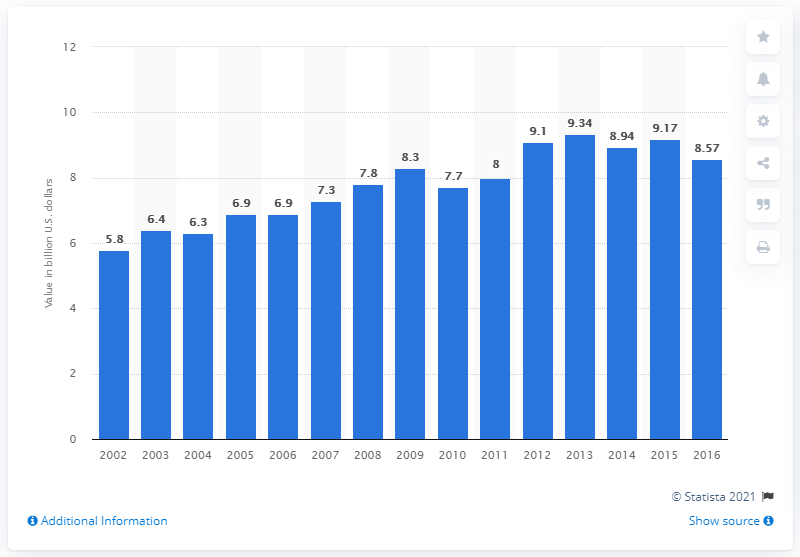Draw attention to some important aspects in this diagram. In 2016, the value of U.S. product shipments of frozen vegetables was approximately $8.57 billion. 